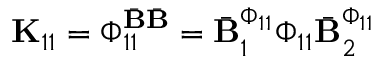<formula> <loc_0><loc_0><loc_500><loc_500>K _ { 1 1 } = \Phi _ { 1 1 } ^ { \bar { B } \bar { B } } = \bar { B } _ { 1 } ^ { \Phi _ { 1 1 } } \Phi _ { 1 1 } \bar { B } _ { 2 } ^ { \Phi _ { 1 1 } }</formula> 